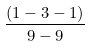<formula> <loc_0><loc_0><loc_500><loc_500>\frac { ( 1 - 3 - 1 ) } { 9 - 9 }</formula> 